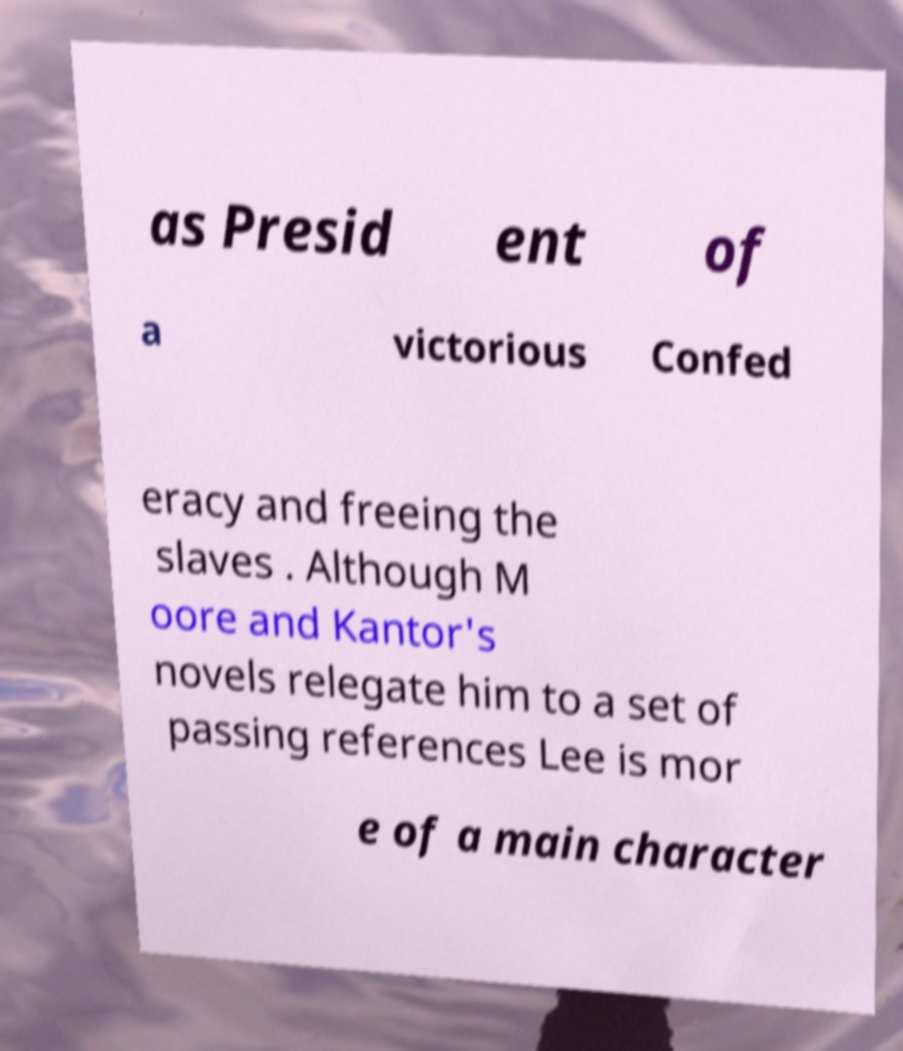There's text embedded in this image that I need extracted. Can you transcribe it verbatim? as Presid ent of a victorious Confed eracy and freeing the slaves . Although M oore and Kantor's novels relegate him to a set of passing references Lee is mor e of a main character 